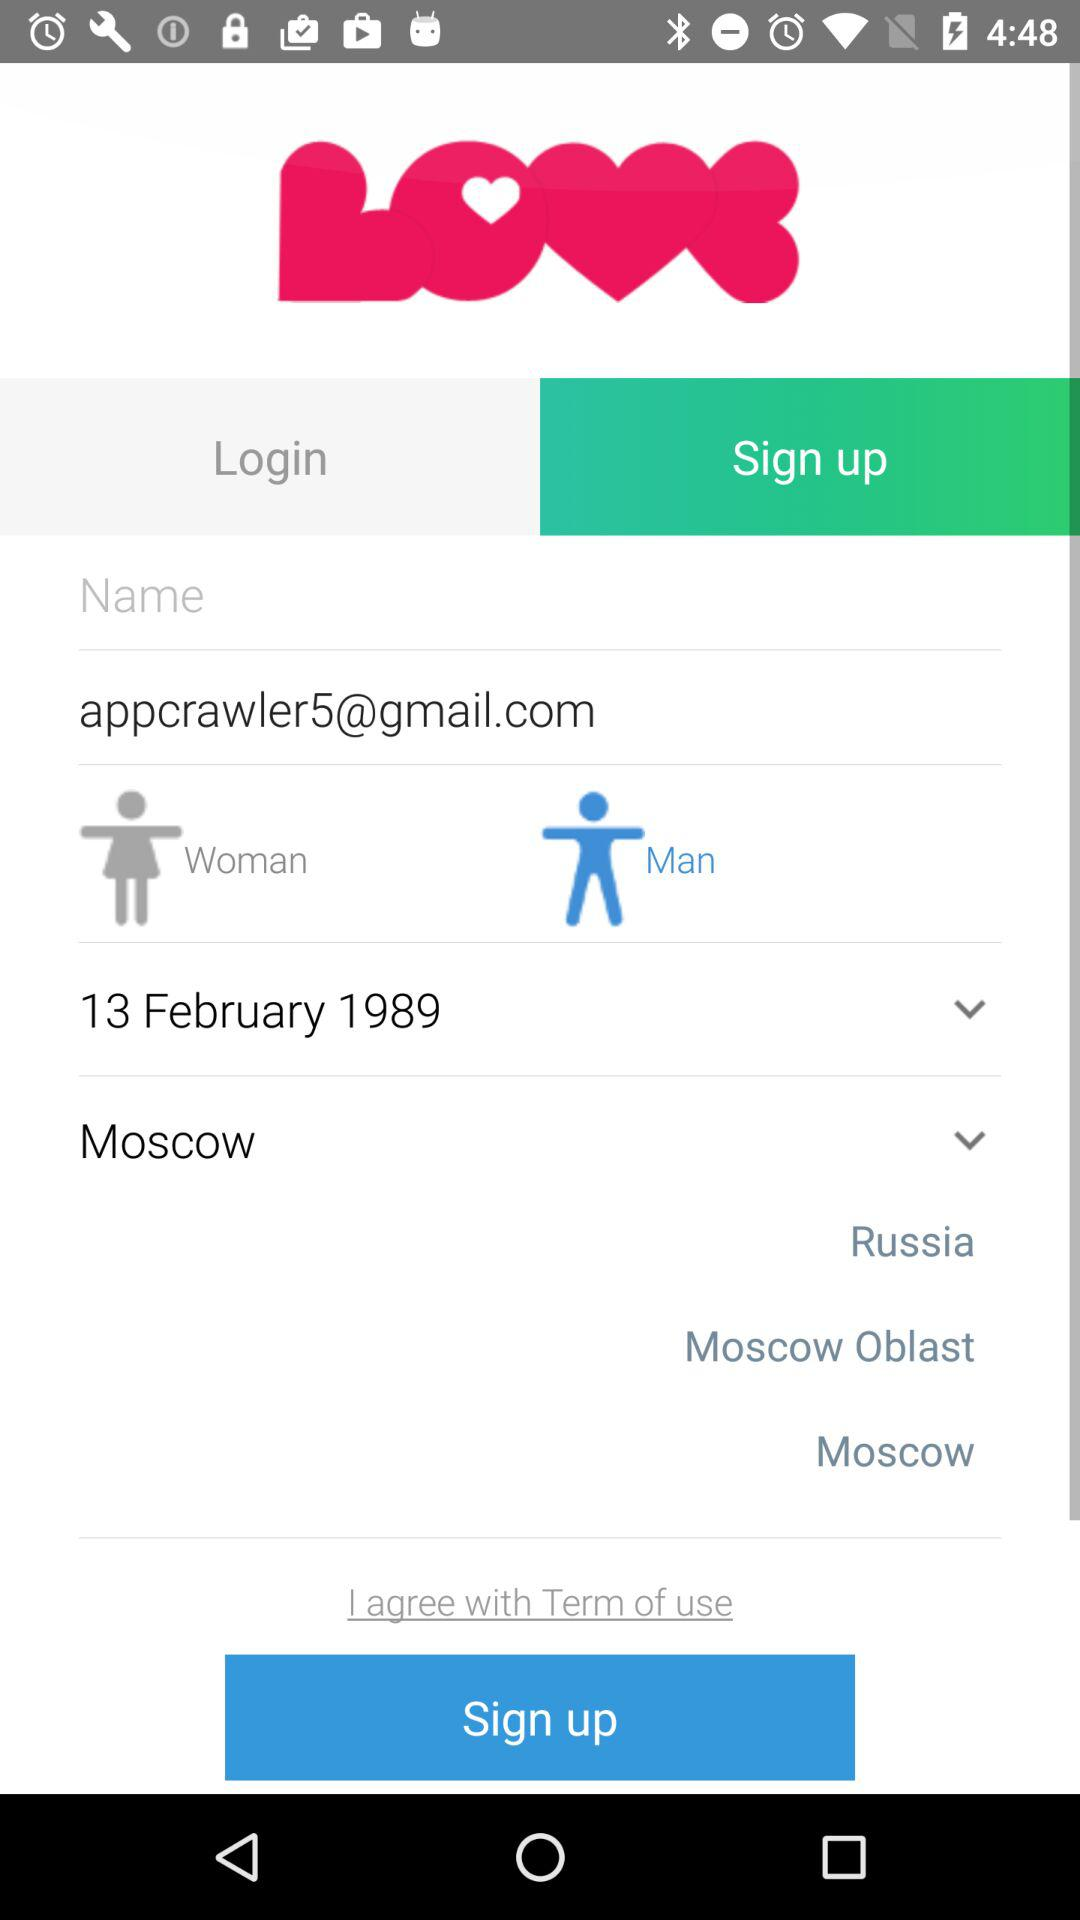What is the date of birth? The date of birth is February 13, 1989. 